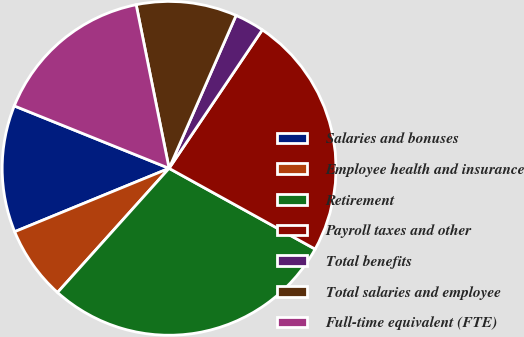<chart> <loc_0><loc_0><loc_500><loc_500><pie_chart><fcel>Salaries and bonuses<fcel>Employee health and insurance<fcel>Retirement<fcel>Payroll taxes and other<fcel>Total benefits<fcel>Total salaries and employee<fcel>Full-time equivalent (FTE)<nl><fcel>12.3%<fcel>7.15%<fcel>28.61%<fcel>23.61%<fcel>2.86%<fcel>9.73%<fcel>15.74%<nl></chart> 